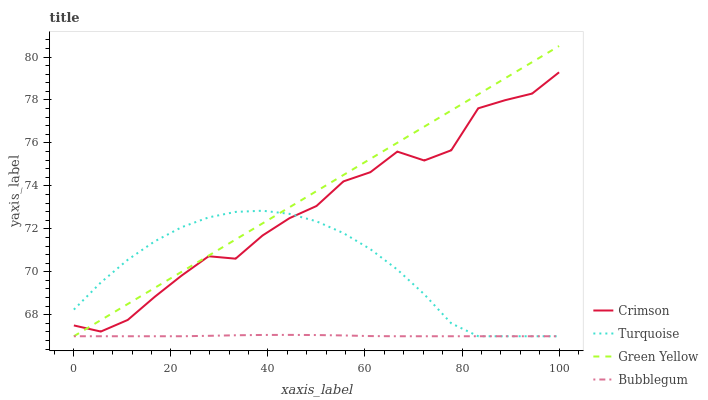Does Bubblegum have the minimum area under the curve?
Answer yes or no. Yes. Does Green Yellow have the maximum area under the curve?
Answer yes or no. Yes. Does Turquoise have the minimum area under the curve?
Answer yes or no. No. Does Turquoise have the maximum area under the curve?
Answer yes or no. No. Is Green Yellow the smoothest?
Answer yes or no. Yes. Is Crimson the roughest?
Answer yes or no. Yes. Is Turquoise the smoothest?
Answer yes or no. No. Is Turquoise the roughest?
Answer yes or no. No. Does Turquoise have the lowest value?
Answer yes or no. Yes. Does Green Yellow have the highest value?
Answer yes or no. Yes. Does Turquoise have the highest value?
Answer yes or no. No. Is Bubblegum less than Crimson?
Answer yes or no. Yes. Is Crimson greater than Bubblegum?
Answer yes or no. Yes. Does Green Yellow intersect Turquoise?
Answer yes or no. Yes. Is Green Yellow less than Turquoise?
Answer yes or no. No. Is Green Yellow greater than Turquoise?
Answer yes or no. No. Does Bubblegum intersect Crimson?
Answer yes or no. No. 